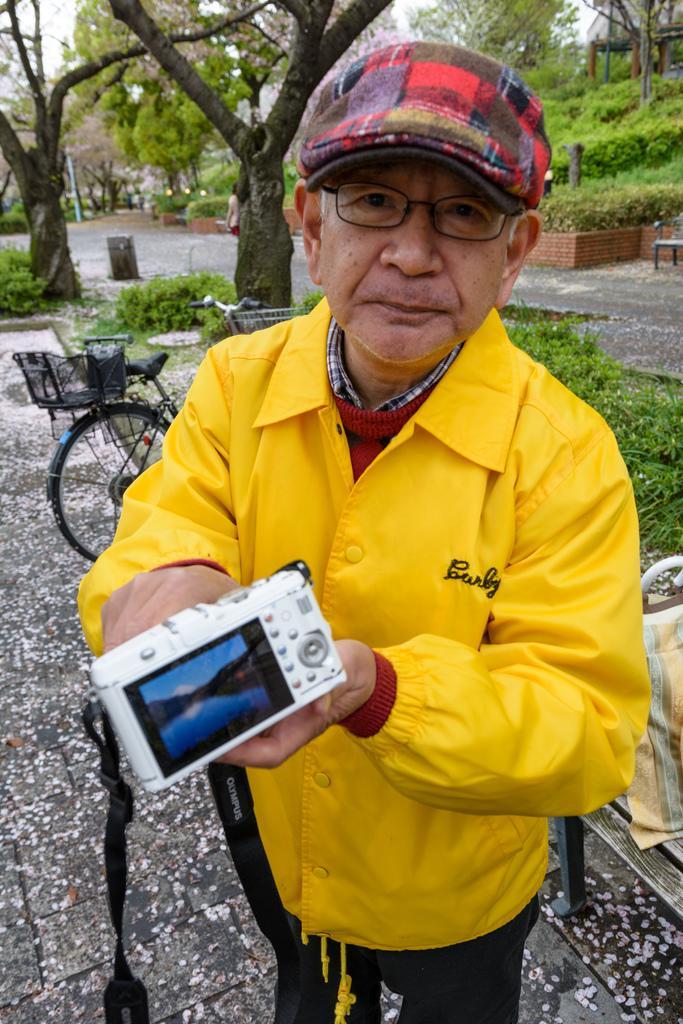Can you describe this image briefly? This picture shows man wore a cap on his head and a coat and he is holding a camera in his hands and he wore spectacles on his face and we see a bicycle and few trees and we see a bench and a bag on it. 